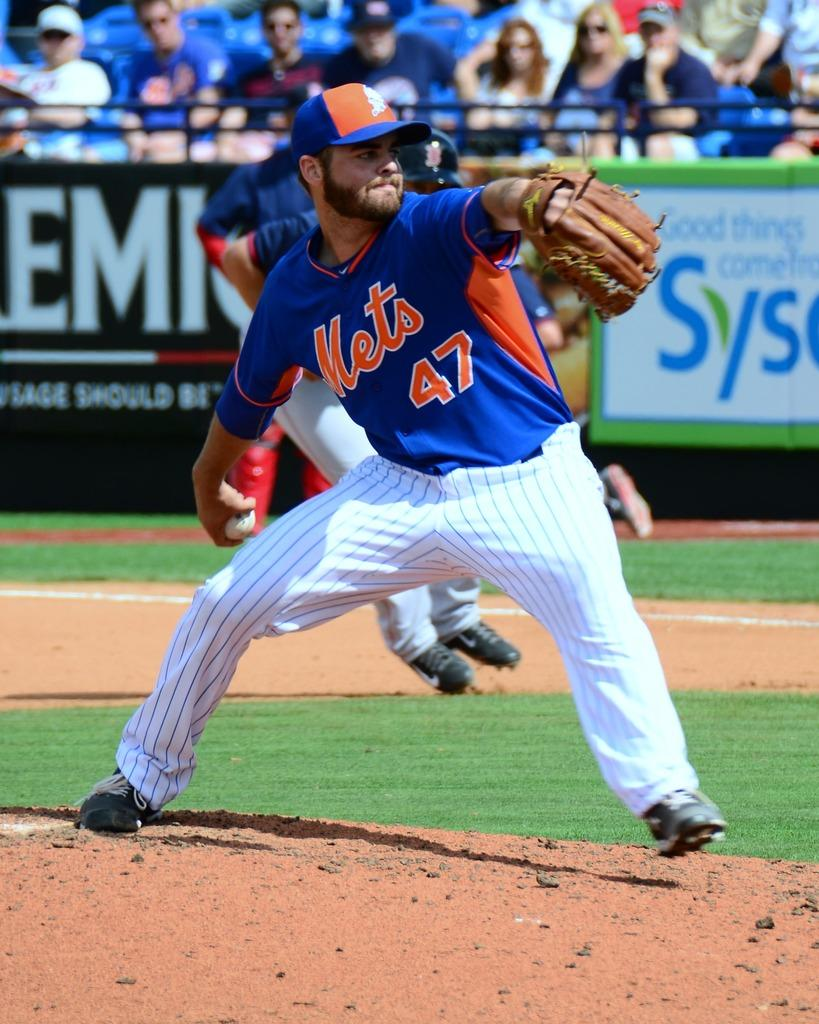Provide a one-sentence caption for the provided image. a mets baseball player with the number 47 on his jersey. 